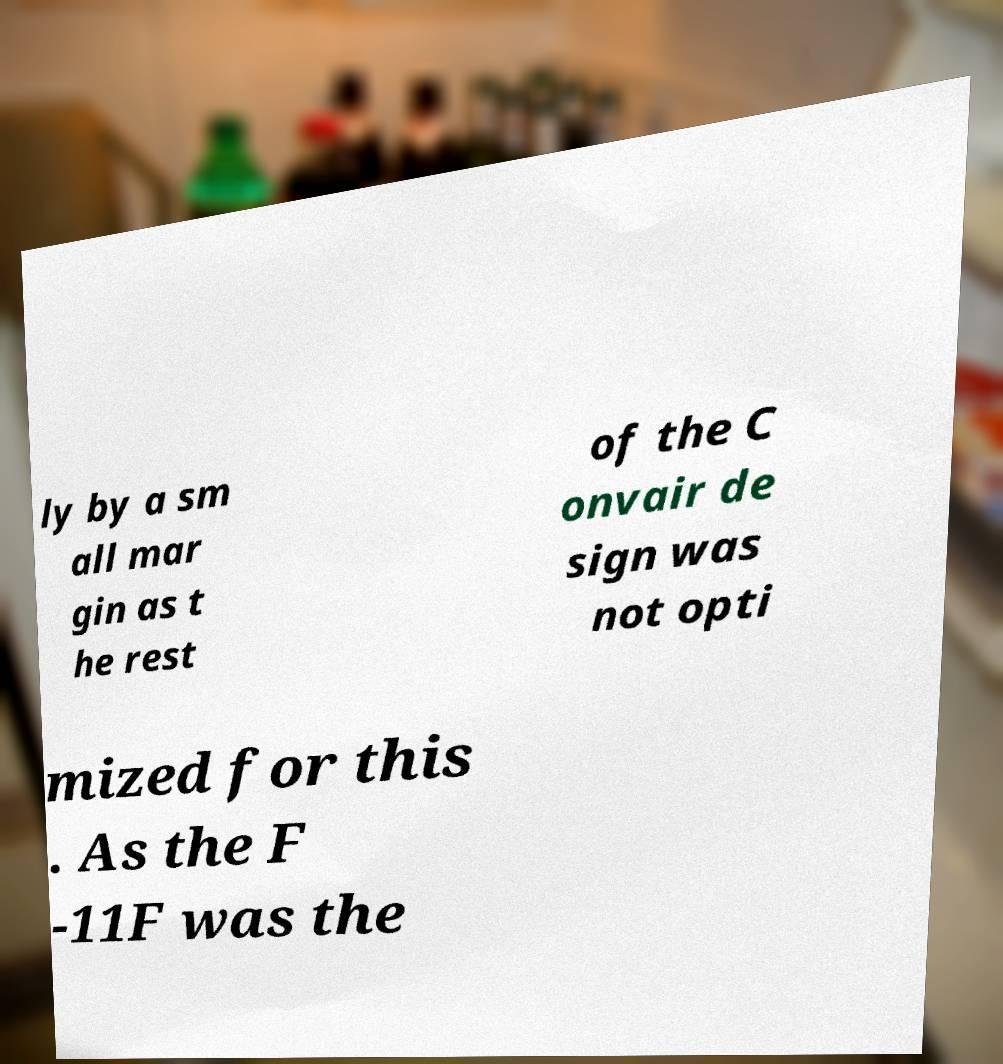Could you assist in decoding the text presented in this image and type it out clearly? ly by a sm all mar gin as t he rest of the C onvair de sign was not opti mized for this . As the F -11F was the 